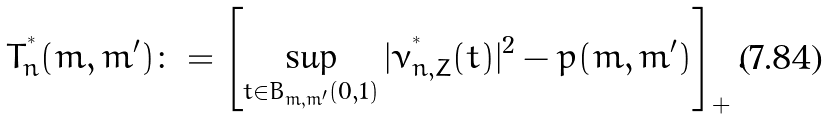Convert formula to latex. <formula><loc_0><loc_0><loc_500><loc_500>T _ { n } ^ { ^ { * } } ( m , m ^ { \prime } ) \colon = \left [ \sup _ { t \in B _ { m , m ^ { \prime } } ( 0 , 1 ) } | \nu _ { n , Z } ^ { ^ { * } } ( t ) | ^ { 2 } - p ( m , m ^ { \prime } ) \right ] _ { + } .</formula> 